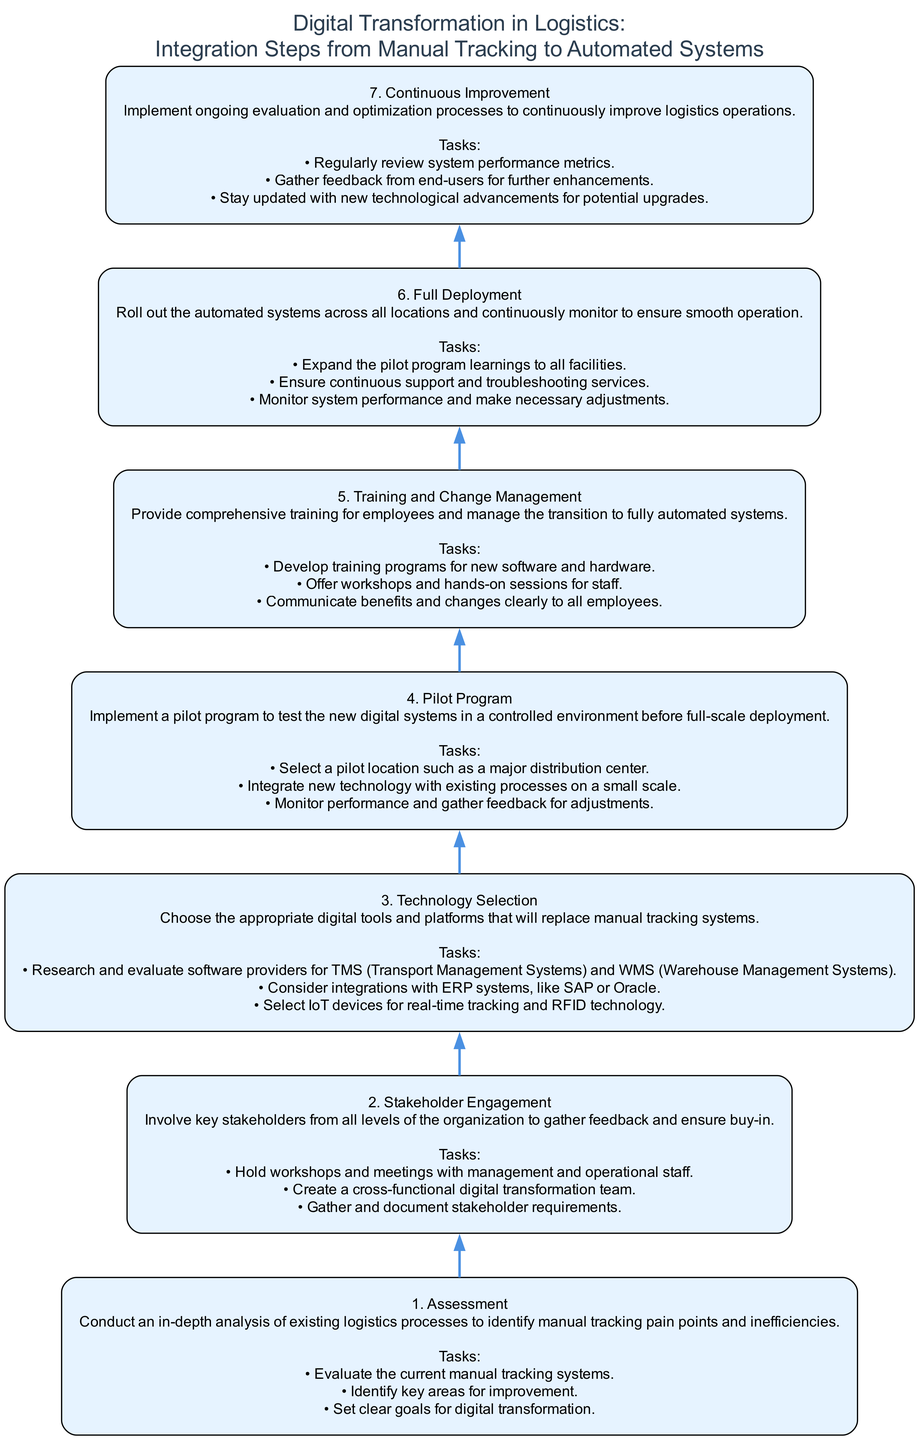What is the first step in the digital transformation process? The diagram starts with the first node labeled as "1. Assessment," indicating it is the initial step in the process of digital transformation.
Answer: Assessment How many tasks are associated with the "Stakeholder Engagement" step? By reviewing the step labeled "2. Stakeholder Engagement," it lists three specific tasks, confirming the number of tasks linked to this step.
Answer: 3 Which step comes directly after the "Pilot Program"? The diagram shows a directional flow from "4. Pilot Program" to "5. Training and Change Management," indicating the next step in the sequence.
Answer: Training and Change Management What is the primary goal of the "Full Deployment" step? The description of "6. Full Deployment" focuses on rolling out automated systems across all locations and maintaining continuous support, which outlines the key objective for this step.
Answer: Roll out the automated systems Which step involves selecting technology for logistics? In the flow chart, "3. Technology Selection" is the specific step that mentions choosing appropriate digital tools and platforms, directly addressing the question about technology selection.
Answer: Technology Selection What type of program is implemented after stakeholder engagement? Following "2. Stakeholder Engagement," the diagram illustrates that a "3. Technology Selection" lead to a program focusing on pilots, which is the next logical step.
Answer: Pilot Program Which step emphasizes continuous evaluation and enhancements? The last step, "7. Continuous Improvement," explicitly states its goal of ongoing evaluation and optimization processes, emphasizing its focus on continuous advancement.
Answer: Continuous Improvement How many total steps are illustrated in the diagram? By counting the distinct steps listed vertically in the diagram, there are seven sequential steps depicted in the flow chart.
Answer: 7 What are the key tasks listed in the "Training and Change Management" step? The "5. Training and Change Management" step includes three specific tasks related to employee training and managing transition, totaling these tasks gives the key focus areas.
Answer: Develop training programs, Offer workshops and hands-on sessions, Communicate benefits and changes clearly 